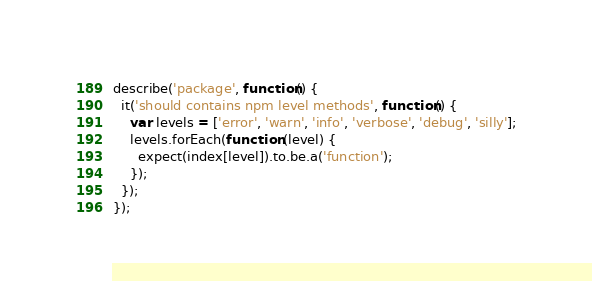Convert code to text. <code><loc_0><loc_0><loc_500><loc_500><_JavaScript_>
describe('package', function() {
  it('should contains npm level methods', function() {
    var levels = ['error', 'warn', 'info', 'verbose', 'debug', 'silly'];
    levels.forEach(function (level) {
      expect(index[level]).to.be.a('function');
    });
  });
});</code> 